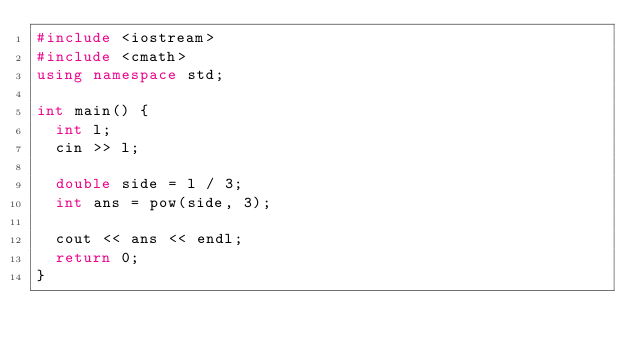Convert code to text. <code><loc_0><loc_0><loc_500><loc_500><_C++_>#include <iostream>
#include <cmath>
using namespace std;

int main() {
	int l;
	cin >> l;

	double side = l / 3;
	int ans = pow(side, 3);

	cout << ans << endl;
	return 0;
}</code> 